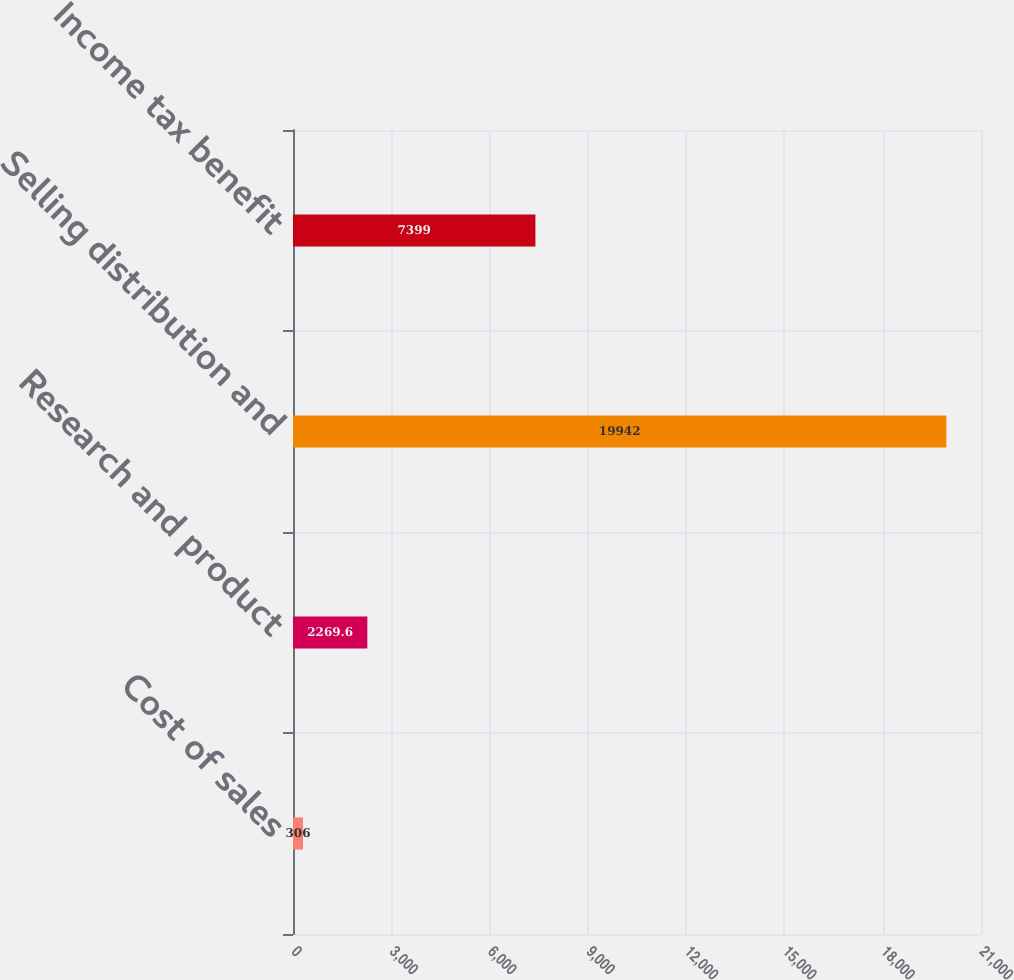Convert chart. <chart><loc_0><loc_0><loc_500><loc_500><bar_chart><fcel>Cost of sales<fcel>Research and product<fcel>Selling distribution and<fcel>Income tax benefit<nl><fcel>306<fcel>2269.6<fcel>19942<fcel>7399<nl></chart> 